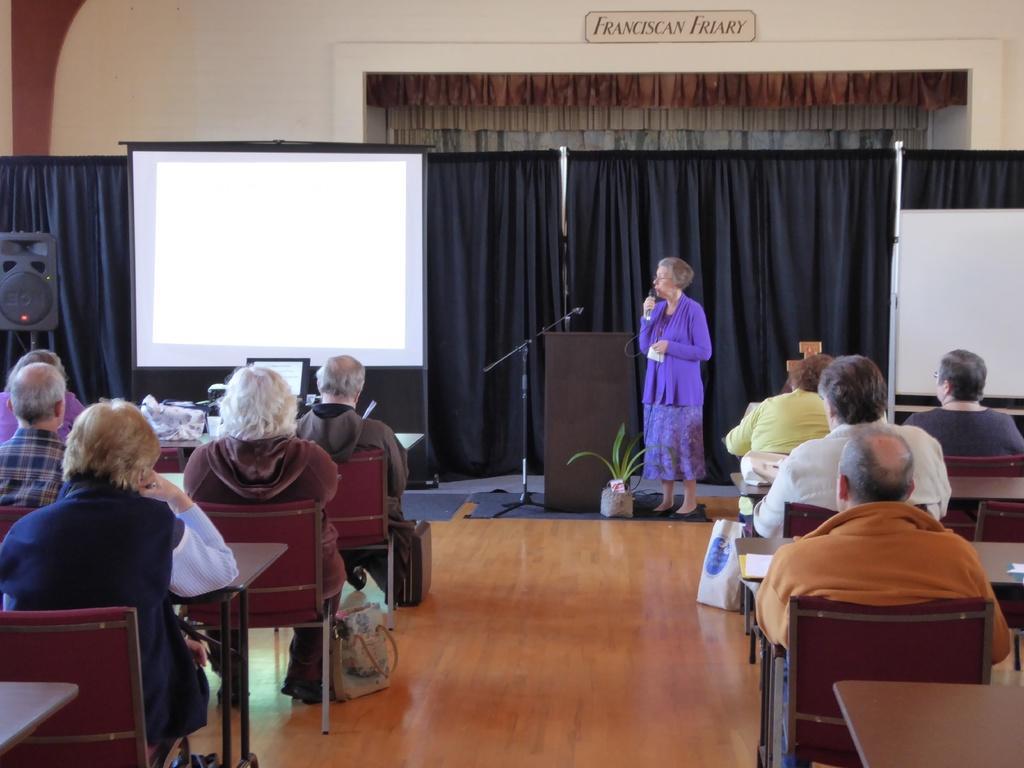Could you give a brief overview of what you see in this image? This picture describes about group of people who are all seated on the chairs except one woman standing in front of them and seeing a projector screen besides of projector screen there is a speaker and we can see a black sheets, podium and a plant. 